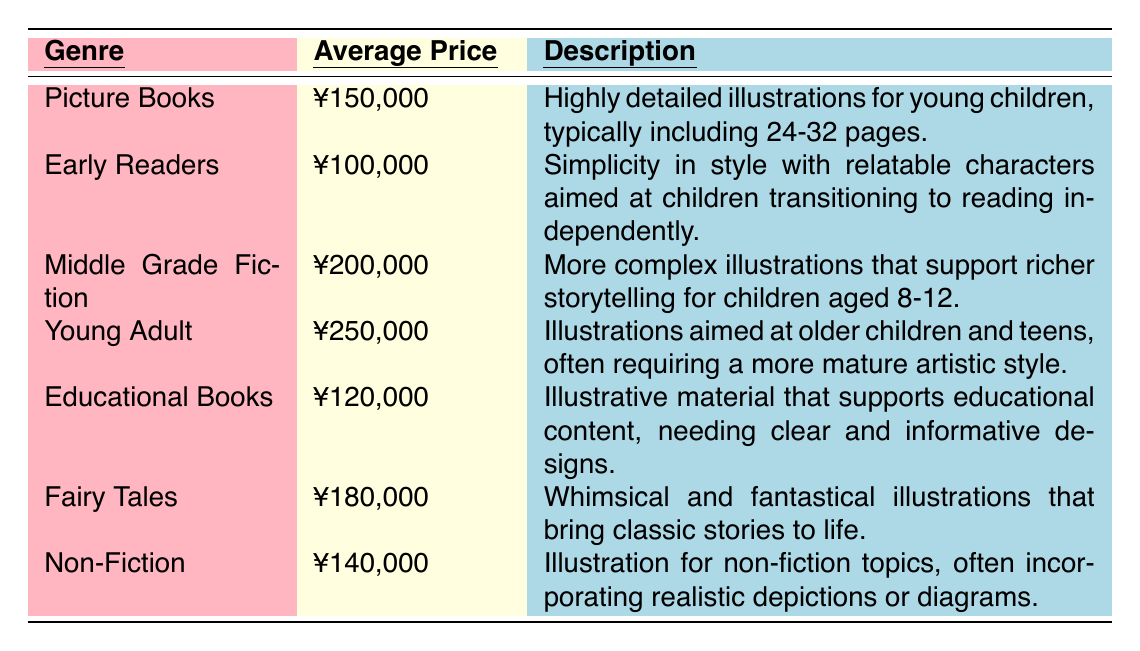What is the average price for Picture Books? The table states that the average price for Picture Books is listed as ¥150,000.
Answer: ¥150,000 How much is the average price of Fairy Tales compared to Early Readers? The average price for Fairy Tales is ¥180,000 and for Early Readers, it is ¥100,000. The difference is ¥180,000 - ¥100,000 = ¥80,000.
Answer: ¥80,000 Is the average price for Young Adult illustrations higher than for Middle Grade Fiction? The table shows the average price for Young Adult is ¥250,000, while Middle Grade Fiction is ¥200,000. Since ¥250,000 is greater than ¥200,000, the statement is true.
Answer: Yes What is the total average price for Educational Books and Non-Fiction? The average price for Educational Books is ¥120,000 and for Non-Fiction, it is ¥140,000. Adding these together gives ¥120,000 + ¥140,000 = ¥260,000.
Answer: ¥260,000 Which genre has the lowest average price? By comparing all average prices, Early Readers has the lowest at ¥100,000.
Answer: Early Readers How does the average price of Middle Grade Fiction compare to the average price of Children's Educational Books? Middle Grade Fiction is ¥200,000 and Educational Books are ¥120,000. The difference is ¥200,000 - ¥120,000 = ¥80,000, indicating Middle Grade Fiction is higher.
Answer: ¥80,000 higher If I wanted to illustrate both a Picture Book and a Fairy Tale, what would be the total average price? The average price for Picture Books is ¥150,000 and for Fairy Tales is ¥180,000. Adding these gives ¥150,000 + ¥180,000 = ¥330,000.
Answer: ¥330,000 Which genres are priced above ¥150,000? The genres priced above ¥150,000 are Middle Grade Fiction (¥200,000), Young Adult (¥250,000), and Fairy Tales (¥180,000).
Answer: Middle Grade Fiction, Young Adult, Fairy Tales What is the average price of all the genres combined? The total average price is the sum of all average prices (¥150,000 + ¥100,000 + ¥200,000 + ¥250,000 + ¥120,000 + ¥180,000 + ¥140,000 = ¥1,140,000). Divide this by 7 genres: ¥1,140,000 / 7 = ¥162,857.
Answer: ¥162,857 Is the average price for Non-Fiction illustrations less than ¥150,000? The average price for Non-Fiction is ¥140,000, which is less than ¥150,000. Therefore, the statement is true.
Answer: Yes 